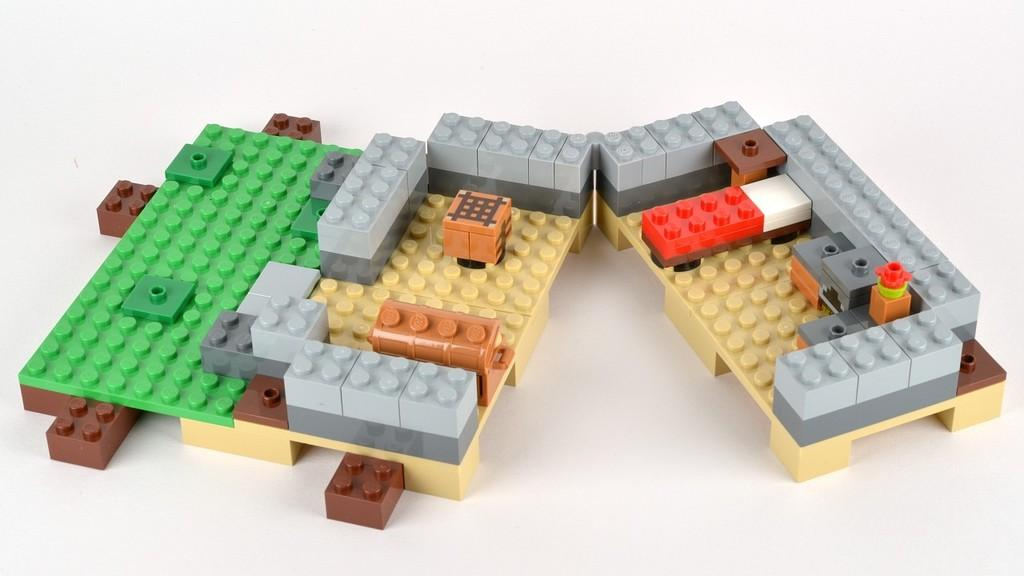What type of objects are in the image? There are miniature blocks in the image. Where are the blocks located? The blocks are on a desk. What is the color of the desk? The desk is white in color. How many stamps are on the basketball in the image? There are no stamps or basketballs present in the image; it features miniature blocks on a white desk. 